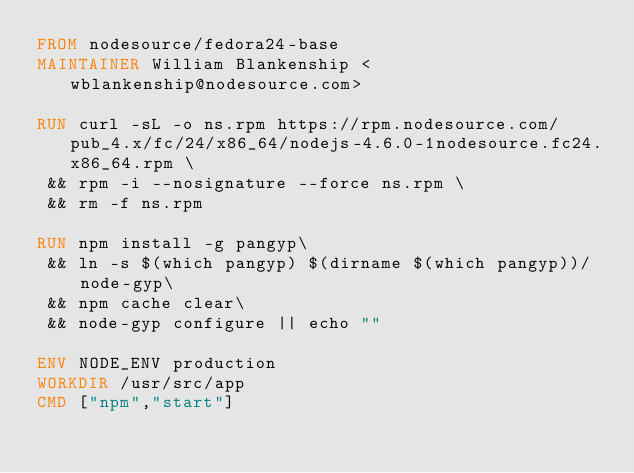Convert code to text. <code><loc_0><loc_0><loc_500><loc_500><_Dockerfile_>FROM nodesource/fedora24-base
MAINTAINER William Blankenship <wblankenship@nodesource.com>

RUN curl -sL -o ns.rpm https://rpm.nodesource.com/pub_4.x/fc/24/x86_64/nodejs-4.6.0-1nodesource.fc24.x86_64.rpm \
 && rpm -i --nosignature --force ns.rpm \
 && rm -f ns.rpm

RUN npm install -g pangyp\
 && ln -s $(which pangyp) $(dirname $(which pangyp))/node-gyp\
 && npm cache clear\
 && node-gyp configure || echo ""

ENV NODE_ENV production
WORKDIR /usr/src/app
CMD ["npm","start"]</code> 